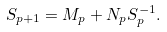<formula> <loc_0><loc_0><loc_500><loc_500>S _ { p + 1 } = M _ { p } + N _ { p } S _ { p } ^ { - 1 } .</formula> 